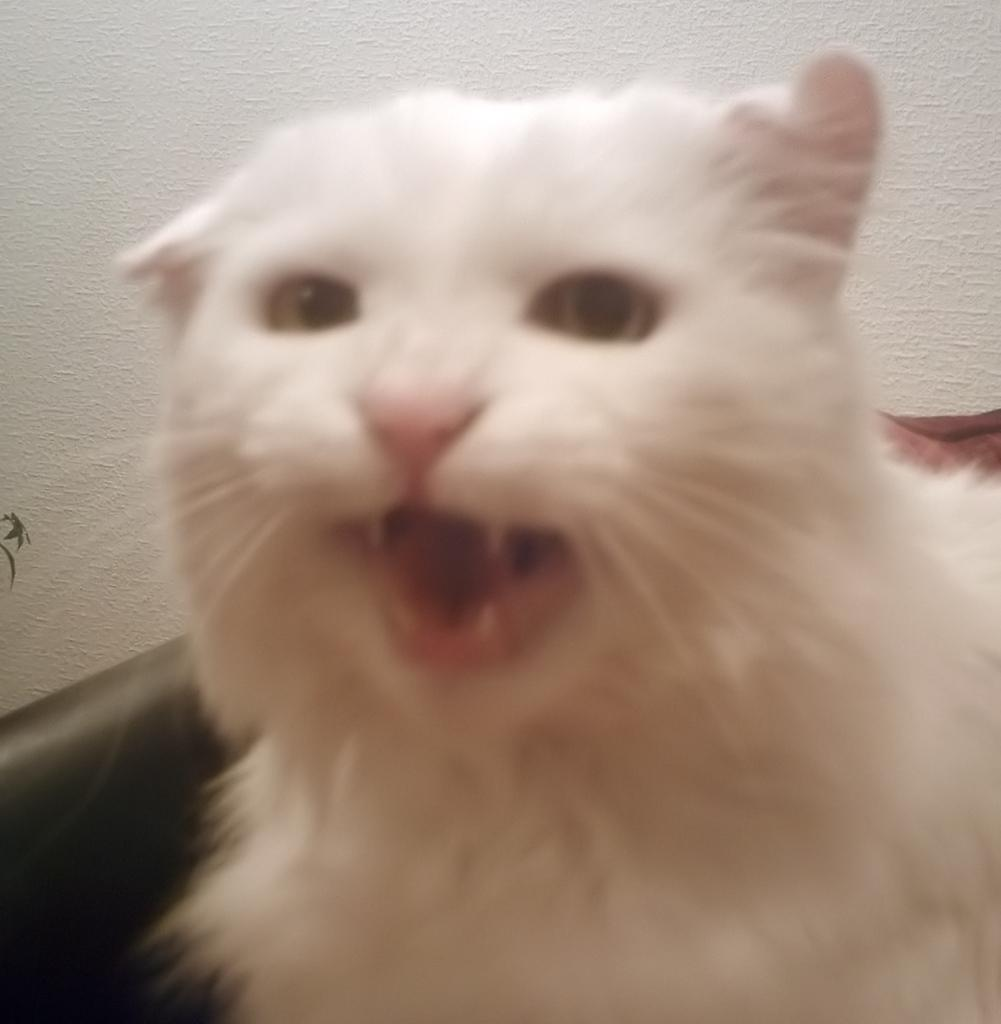What type of animal is in the foreground of the image? There is a white color cat in the foreground of the image. What is the cat doing in the image? The cat has an open mouth in the image. What can be seen in the background of the image? There is a black couch and a wall in the background of the image. Can you tell me how many beggars are visible in the image? There are no beggars present in the image; it features a white color cat with an open mouth in the foreground and a black couch and a wall in the background. 